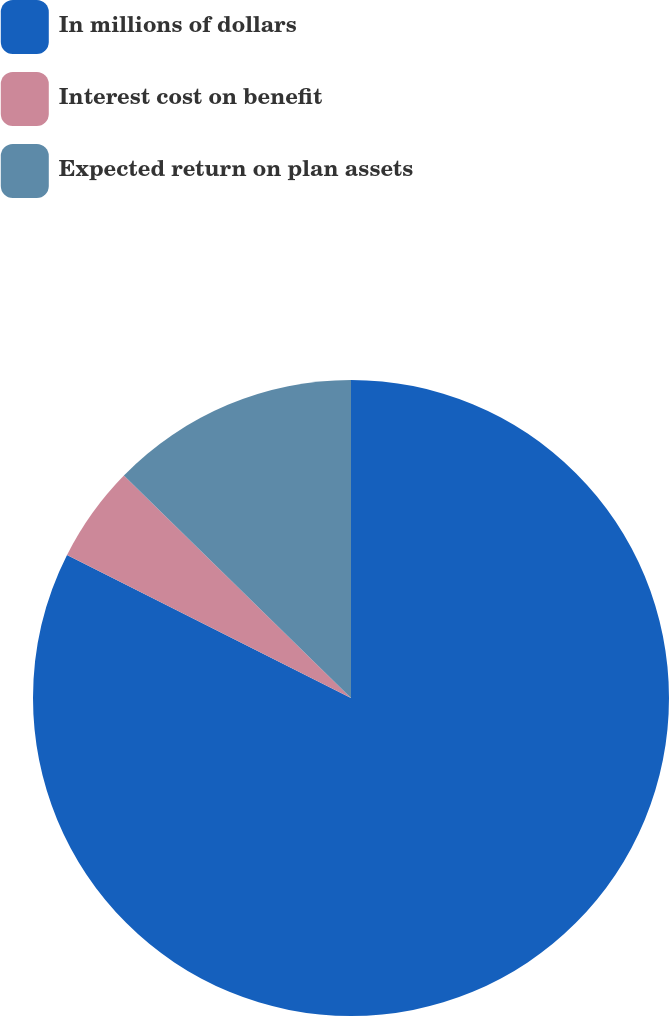Convert chart to OTSL. <chart><loc_0><loc_0><loc_500><loc_500><pie_chart><fcel>In millions of dollars<fcel>Interest cost on benefit<fcel>Expected return on plan assets<nl><fcel>82.43%<fcel>4.91%<fcel>12.66%<nl></chart> 